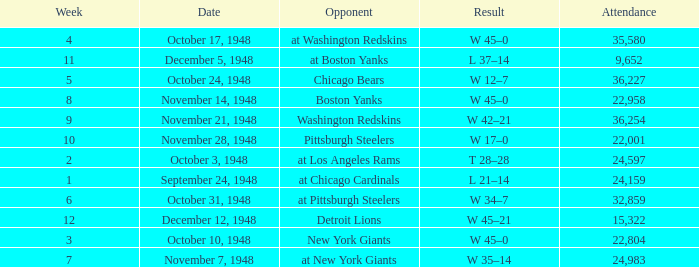What is the lowest value for Week, when the Attendance is greater than 22,958, and when the Opponent is At Chicago Cardinals? 1.0. 